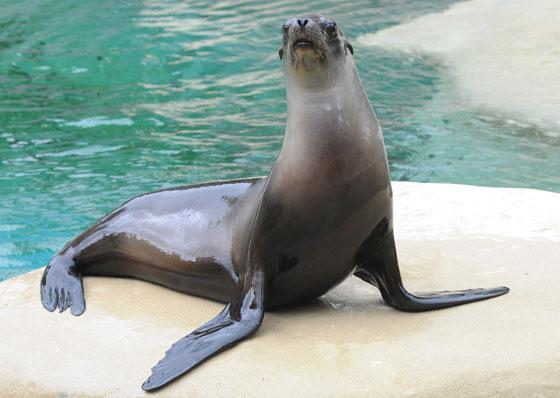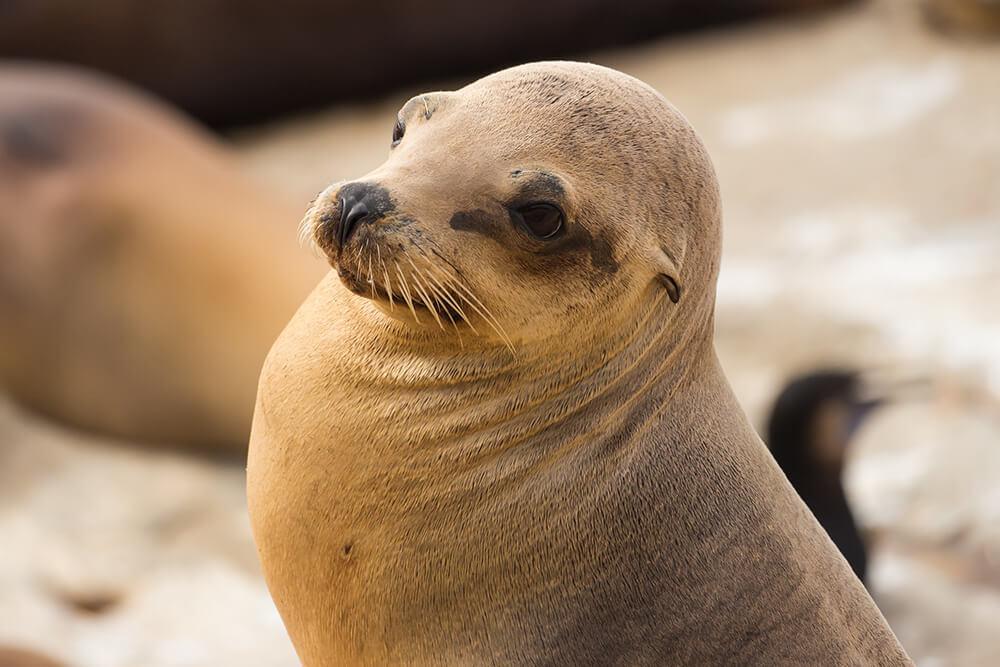The first image is the image on the left, the second image is the image on the right. Analyze the images presented: Is the assertion "there is a body of water on the right image" valid? Answer yes or no. No. 